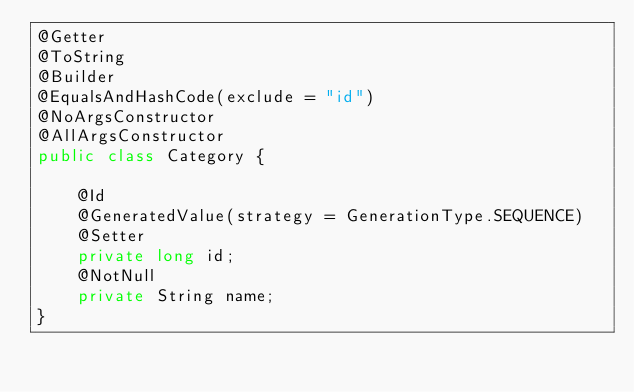Convert code to text. <code><loc_0><loc_0><loc_500><loc_500><_Java_>@Getter
@ToString
@Builder
@EqualsAndHashCode(exclude = "id")
@NoArgsConstructor
@AllArgsConstructor
public class Category {

    @Id
    @GeneratedValue(strategy = GenerationType.SEQUENCE)
    @Setter
    private long id;
    @NotNull
    private String name;
}
</code> 